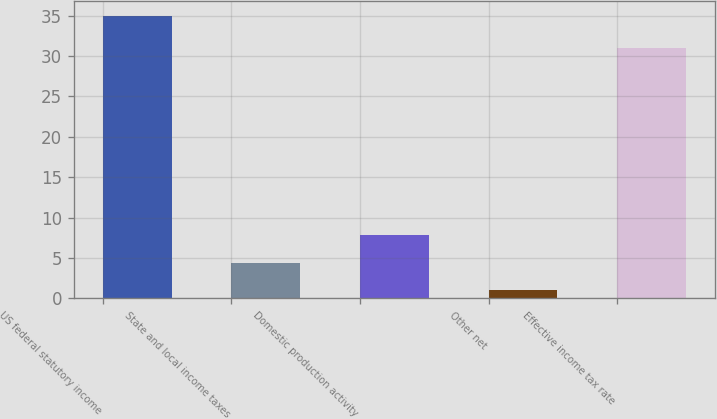Convert chart. <chart><loc_0><loc_0><loc_500><loc_500><bar_chart><fcel>US federal statutory income<fcel>State and local income taxes<fcel>Domestic production activity<fcel>Other net<fcel>Effective income tax rate<nl><fcel>35<fcel>4.4<fcel>7.8<fcel>1<fcel>31<nl></chart> 